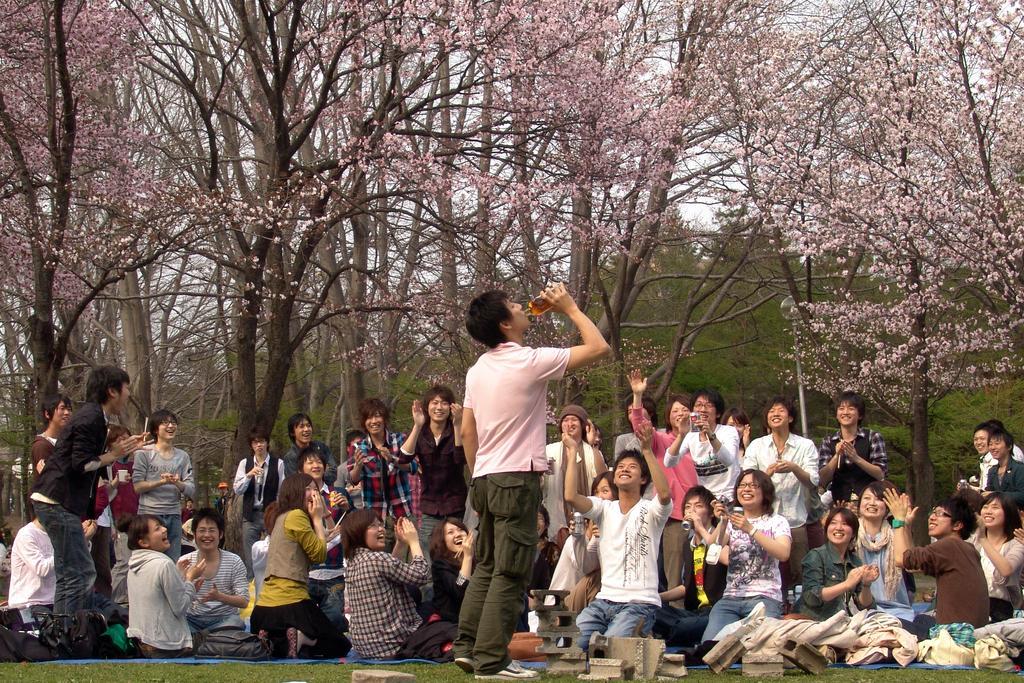Could you give a brief overview of what you see in this image? In this picture I can see few people are standing and few are sitting and I can see a man standing and drinking with the help of a bottle in his hand and few are clapping and I can see trees and a sky in the back and I can see grass on the ground. 